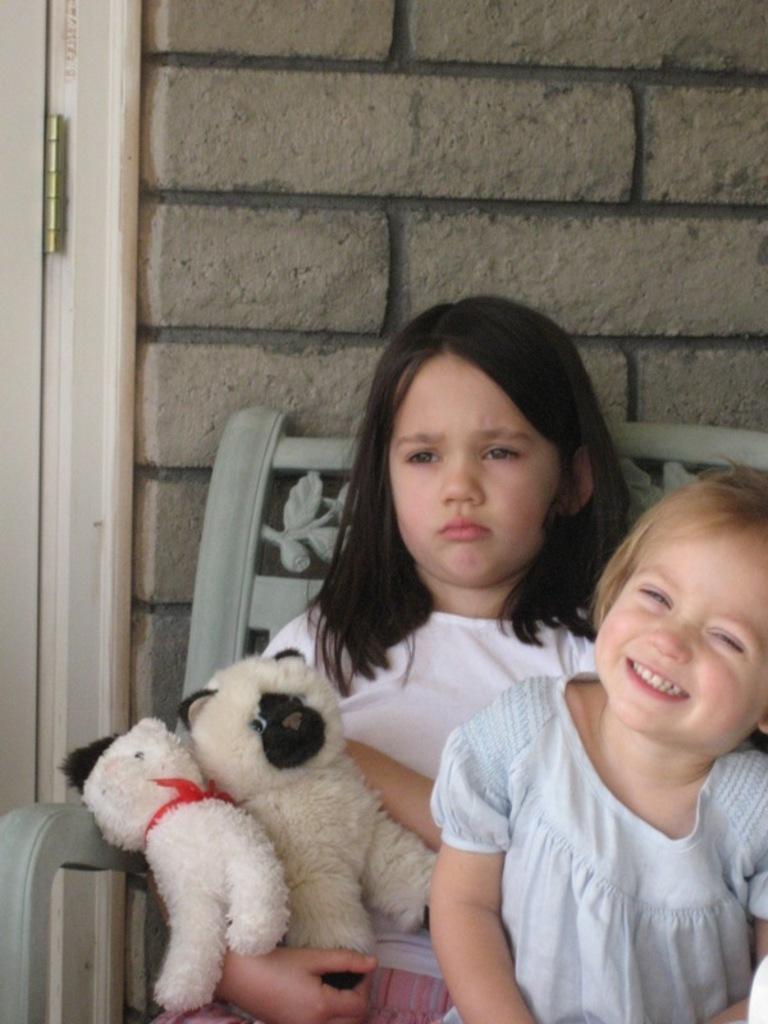How would you summarize this image in a sentence or two? This picture shows two girls seated on the chairs holding soft toys in her hands 